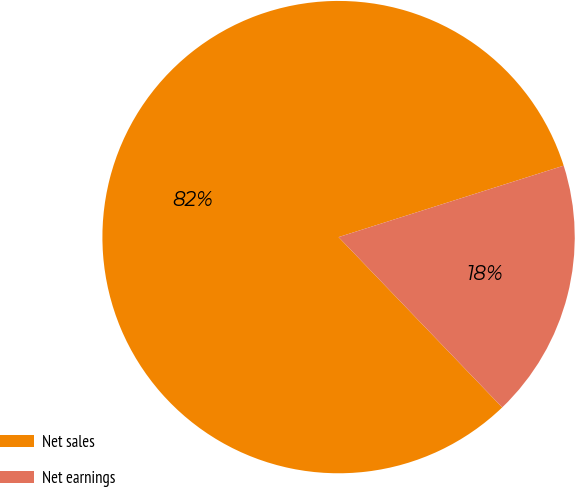Convert chart. <chart><loc_0><loc_0><loc_500><loc_500><pie_chart><fcel>Net sales<fcel>Net earnings<nl><fcel>82.29%<fcel>17.71%<nl></chart> 